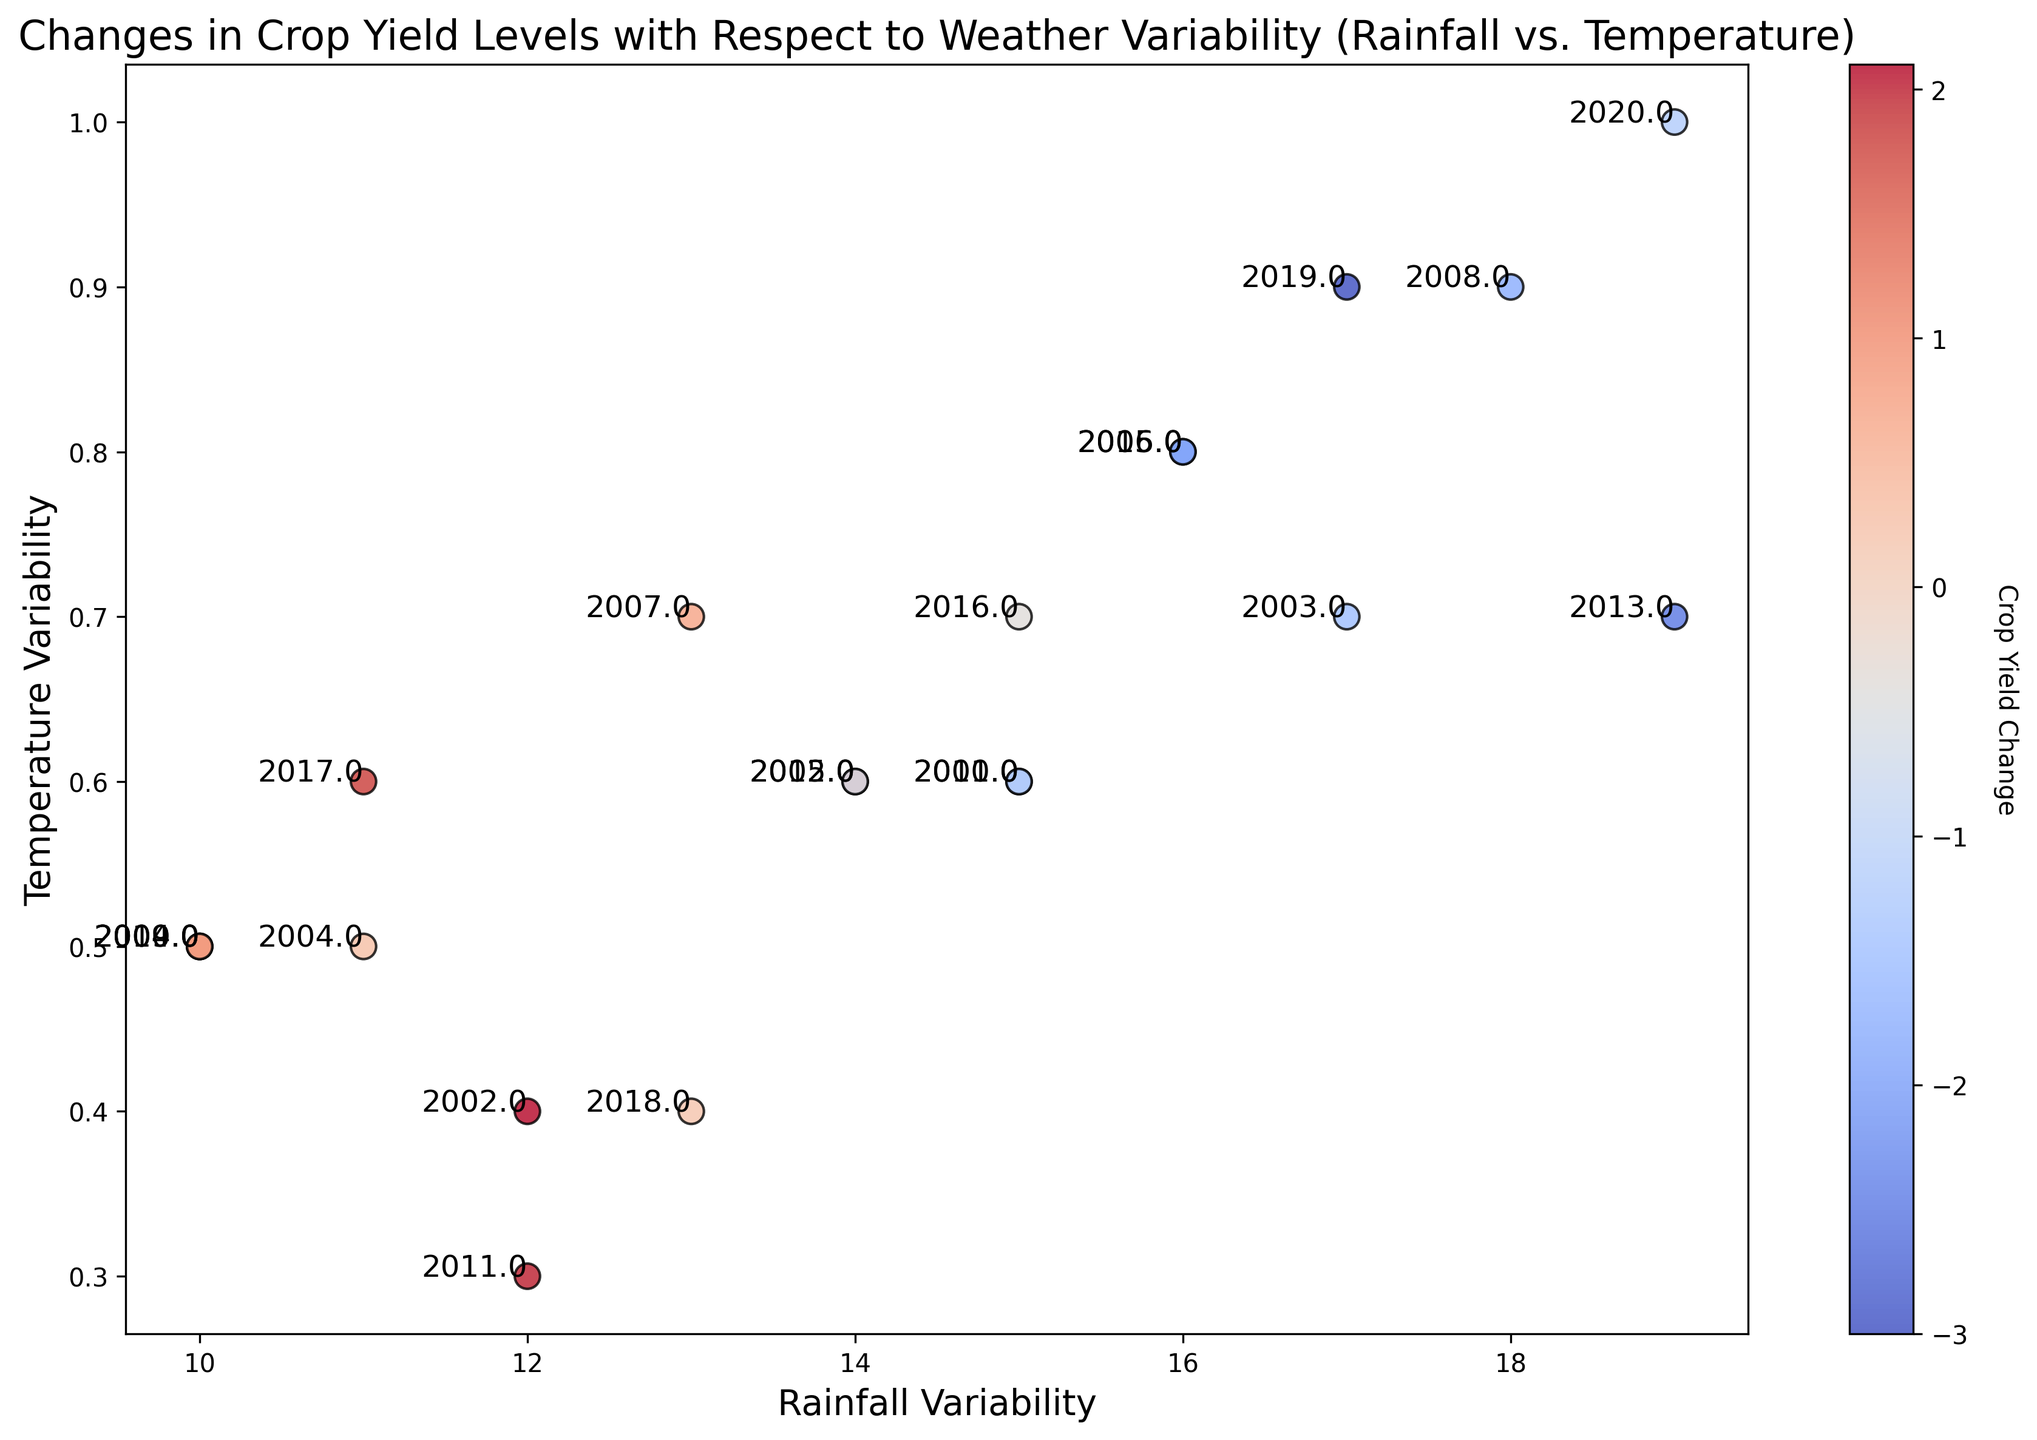What is the color representing the highest crop yield change? The color bar indicates that blue shades represent positive crop yield changes, so we look for the lightest blue shade in the plot. The highest change should be blue around (12, 0.4) with a value of 2.1 for the year 2002.
Answer: Blue Which year had the most negative crop yield change? The most negative crop yield change would correspond to the deepest red color. According to the plot, the deepest red shade is around (17, 0.9) and shows a value of -3.0 for the year 2019.
Answer: 2019 How does crop yield change with an increase in temperature variability above 0.8? Observing the scatter points above 0.8 in temperature variability, we notice they are all shaded in red, indicating a negative crop yield change (e.g., years 2013, 2015, 2016, 2018, 2019, 2020). The conclusion is that crop yield tends to decrease with high temperature variability.
Answer: Decrease Comparing the years 2007 and 2010, which had a better crop yield change, and by how much? For 2007, the crop yield change is 0.7 as indicated next to the scatter point, and for 2010, it is -1.3. Therefore, 2007 had a better crop yield change. The difference is 0.7 - (-1.3) = 2.0.
Answer: 2007, by 2.0 What was the trend in crop yield change from 2017 to 2020? Observing the points between (11, 0.6) for 2017 to (19, 1.0) for 2020, we see a trend of progressively negative crop yield changes, going from 1.8 (positive change) to -1.2 (negative change).
Answer: Decreasing trend What is the average rainfall variability for years with positive crop yield changes? Identify the points with blue shades corresponding to positive changes: 2000, 2002, 2004, 2005, 2007, 2009, 2011, 2014, and 2017. Their rainfall variabilities are 10, 12, 11, 14, 13, 10, 12, 10, 11, respectively. Average = (10 + 12 + 11 + 14 + 13 + 10 + 12 + 10 + 11) / 9 = 11.44.
Answer: 11.44 Which year experienced the greatest negative impact on crop yield with rainfall variability of 15? For rainfall variability of 15, the points are for the years 2001, 2010, and 2016. Their crop yield changes are -0.8, -1.3, and -0.4, respectively. The greatest negative impact is -1.3 in the year 2010.
Answer: 2010 Does higher rainfall variability always lead to higher temperature variability? By visually inspecting the scatter points, increasing rainfall variability does not always correlate with higher temperature variability. Specifically, points are spread across the temperature variability axis.
Answer: No 